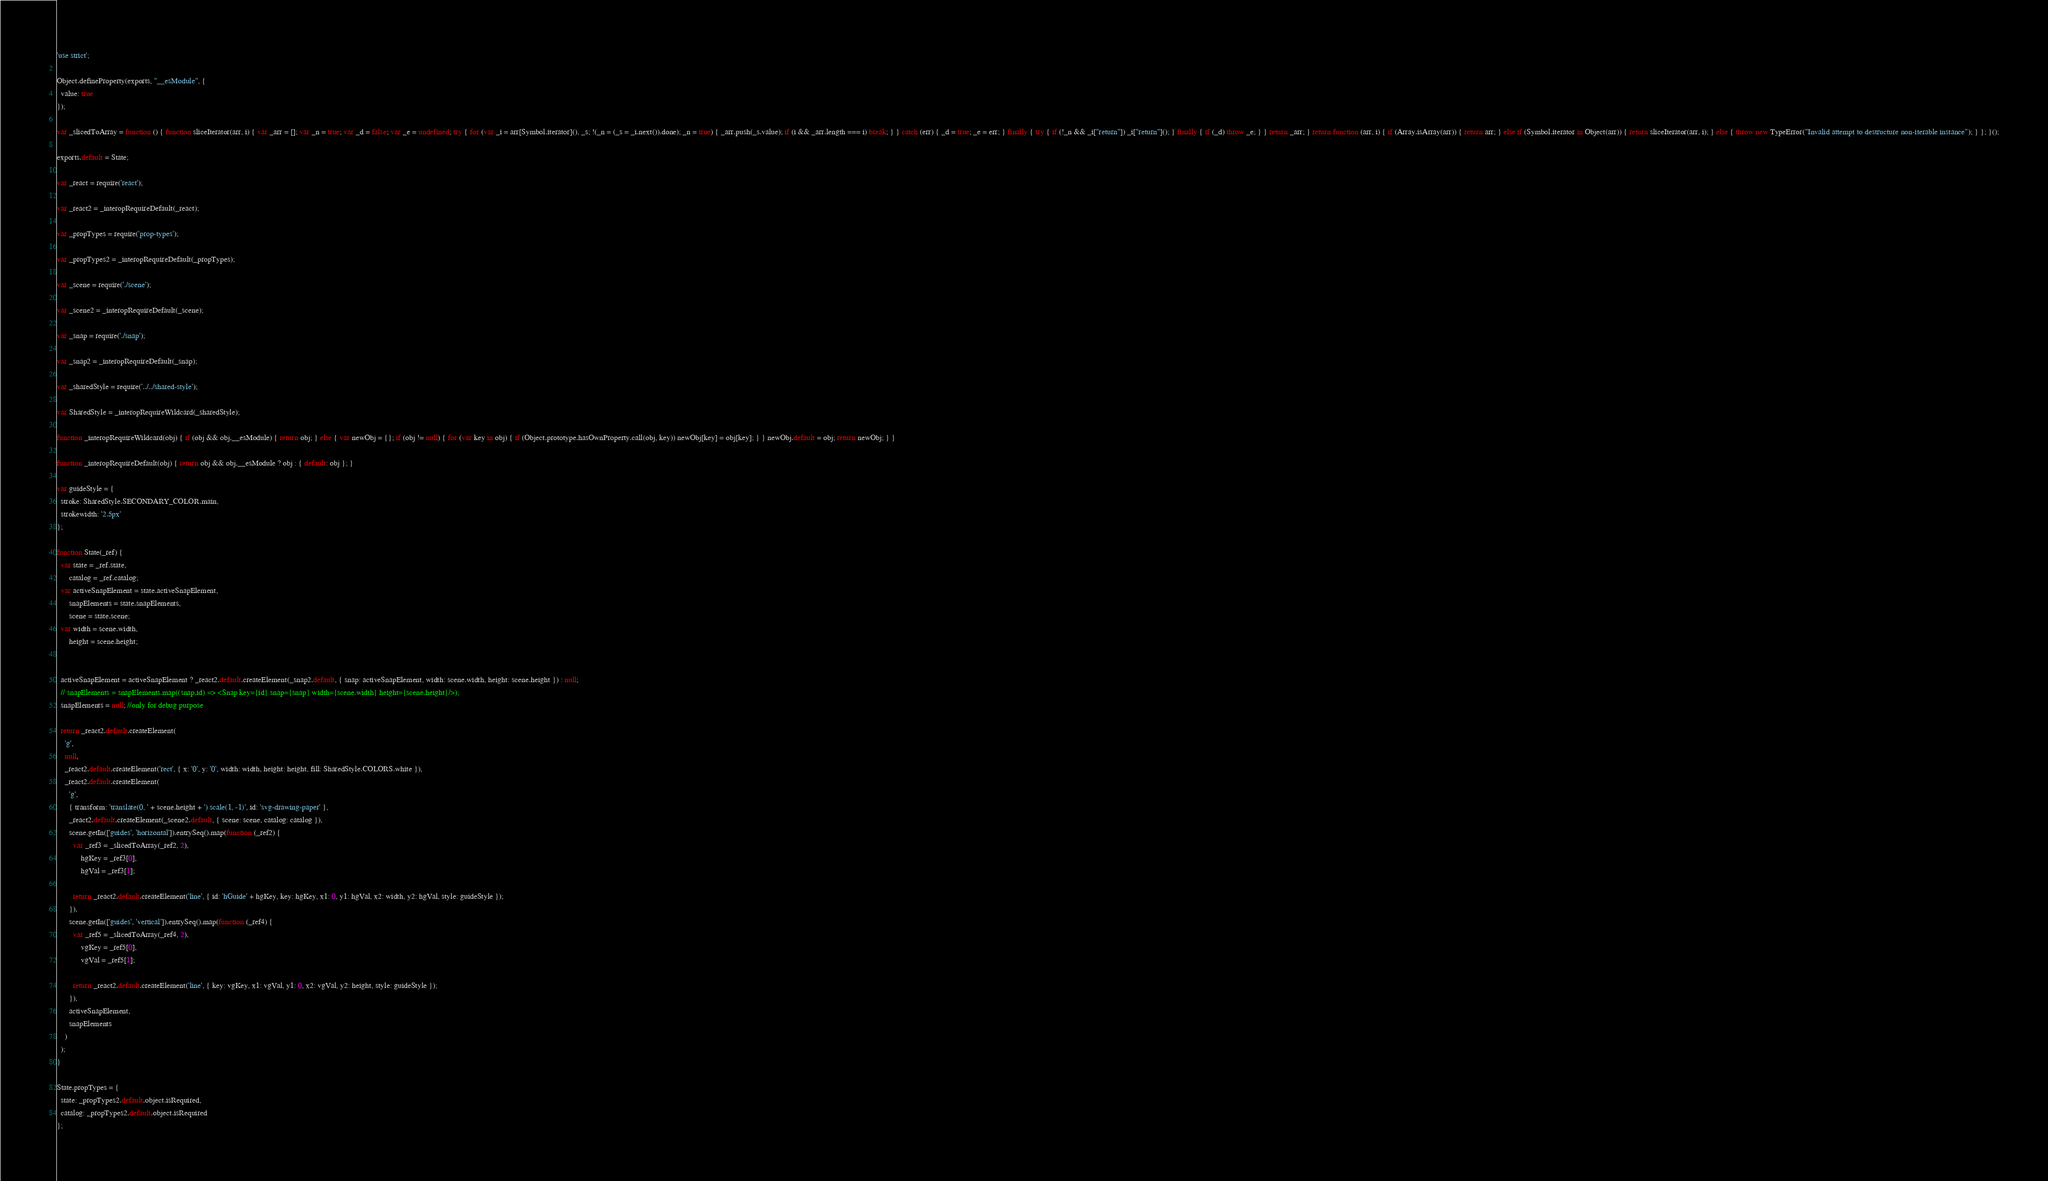Convert code to text. <code><loc_0><loc_0><loc_500><loc_500><_JavaScript_>'use strict';

Object.defineProperty(exports, "__esModule", {
  value: true
});

var _slicedToArray = function () { function sliceIterator(arr, i) { var _arr = []; var _n = true; var _d = false; var _e = undefined; try { for (var _i = arr[Symbol.iterator](), _s; !(_n = (_s = _i.next()).done); _n = true) { _arr.push(_s.value); if (i && _arr.length === i) break; } } catch (err) { _d = true; _e = err; } finally { try { if (!_n && _i["return"]) _i["return"](); } finally { if (_d) throw _e; } } return _arr; } return function (arr, i) { if (Array.isArray(arr)) { return arr; } else if (Symbol.iterator in Object(arr)) { return sliceIterator(arr, i); } else { throw new TypeError("Invalid attempt to destructure non-iterable instance"); } }; }();

exports.default = State;

var _react = require('react');

var _react2 = _interopRequireDefault(_react);

var _propTypes = require('prop-types');

var _propTypes2 = _interopRequireDefault(_propTypes);

var _scene = require('./scene');

var _scene2 = _interopRequireDefault(_scene);

var _snap = require('./snap');

var _snap2 = _interopRequireDefault(_snap);

var _sharedStyle = require('../../shared-style');

var SharedStyle = _interopRequireWildcard(_sharedStyle);

function _interopRequireWildcard(obj) { if (obj && obj.__esModule) { return obj; } else { var newObj = {}; if (obj != null) { for (var key in obj) { if (Object.prototype.hasOwnProperty.call(obj, key)) newObj[key] = obj[key]; } } newObj.default = obj; return newObj; } }

function _interopRequireDefault(obj) { return obj && obj.__esModule ? obj : { default: obj }; }

var guideStyle = {
  stroke: SharedStyle.SECONDARY_COLOR.main,
  strokewidth: '2.5px'
};

function State(_ref) {
  var state = _ref.state,
      catalog = _ref.catalog;
  var activeSnapElement = state.activeSnapElement,
      snapElements = state.snapElements,
      scene = state.scene;
  var width = scene.width,
      height = scene.height;


  activeSnapElement = activeSnapElement ? _react2.default.createElement(_snap2.default, { snap: activeSnapElement, width: scene.width, height: scene.height }) : null;
  // snapElements = snapElements.map((snap,id) => <Snap key={id} snap={snap} width={scene.width} height={scene.height}/>);
  snapElements = null; //only for debug purpose

  return _react2.default.createElement(
    'g',
    null,
    _react2.default.createElement('rect', { x: '0', y: '0', width: width, height: height, fill: SharedStyle.COLORS.white }),
    _react2.default.createElement(
      'g',
      { transform: 'translate(0, ' + scene.height + ') scale(1, -1)', id: 'svg-drawing-paper' },
      _react2.default.createElement(_scene2.default, { scene: scene, catalog: catalog }),
      scene.getIn(['guides', 'horizontal']).entrySeq().map(function (_ref2) {
        var _ref3 = _slicedToArray(_ref2, 2),
            hgKey = _ref3[0],
            hgVal = _ref3[1];

        return _react2.default.createElement('line', { id: 'hGuide' + hgKey, key: hgKey, x1: 0, y1: hgVal, x2: width, y2: hgVal, style: guideStyle });
      }),
      scene.getIn(['guides', 'vertical']).entrySeq().map(function (_ref4) {
        var _ref5 = _slicedToArray(_ref4, 2),
            vgKey = _ref5[0],
            vgVal = _ref5[1];

        return _react2.default.createElement('line', { key: vgKey, x1: vgVal, y1: 0, x2: vgVal, y2: height, style: guideStyle });
      }),
      activeSnapElement,
      snapElements
    )
  );
}

State.propTypes = {
  state: _propTypes2.default.object.isRequired,
  catalog: _propTypes2.default.object.isRequired
};</code> 